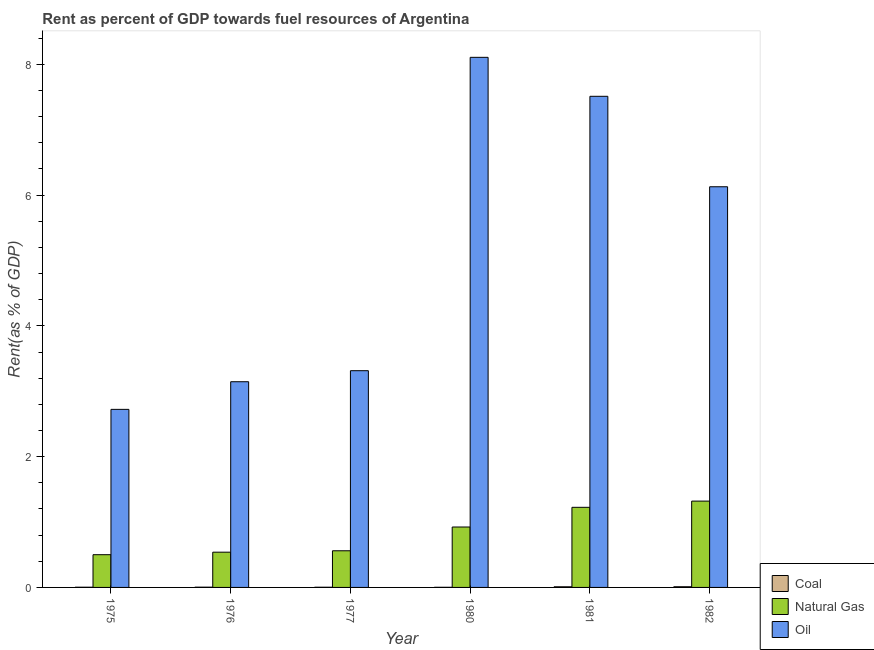Are the number of bars on each tick of the X-axis equal?
Offer a terse response. Yes. How many bars are there on the 1st tick from the left?
Your response must be concise. 3. How many bars are there on the 2nd tick from the right?
Provide a succinct answer. 3. What is the label of the 4th group of bars from the left?
Keep it short and to the point. 1980. What is the rent towards coal in 1982?
Your answer should be very brief. 0.01. Across all years, what is the maximum rent towards oil?
Provide a succinct answer. 8.11. Across all years, what is the minimum rent towards coal?
Give a very brief answer. 0. In which year was the rent towards oil minimum?
Provide a succinct answer. 1975. What is the total rent towards coal in the graph?
Provide a short and direct response. 0.03. What is the difference between the rent towards coal in 1981 and that in 1982?
Keep it short and to the point. -0. What is the difference between the rent towards coal in 1980 and the rent towards natural gas in 1977?
Ensure brevity in your answer.  -0. What is the average rent towards coal per year?
Provide a short and direct response. 0.01. In how many years, is the rent towards oil greater than 7.6 %?
Provide a succinct answer. 1. What is the ratio of the rent towards coal in 1977 to that in 1980?
Ensure brevity in your answer.  1.55. What is the difference between the highest and the second highest rent towards natural gas?
Your response must be concise. 0.1. What is the difference between the highest and the lowest rent towards natural gas?
Your answer should be compact. 0.82. Is the sum of the rent towards natural gas in 1975 and 1980 greater than the maximum rent towards oil across all years?
Ensure brevity in your answer.  Yes. What does the 1st bar from the left in 1976 represents?
Your response must be concise. Coal. What does the 2nd bar from the right in 1977 represents?
Your answer should be compact. Natural Gas. Is it the case that in every year, the sum of the rent towards coal and rent towards natural gas is greater than the rent towards oil?
Give a very brief answer. No. How many years are there in the graph?
Give a very brief answer. 6. Does the graph contain any zero values?
Provide a succinct answer. No. Does the graph contain grids?
Offer a very short reply. No. Where does the legend appear in the graph?
Provide a succinct answer. Bottom right. How are the legend labels stacked?
Keep it short and to the point. Vertical. What is the title of the graph?
Keep it short and to the point. Rent as percent of GDP towards fuel resources of Argentina. Does "Travel services" appear as one of the legend labels in the graph?
Offer a terse response. No. What is the label or title of the X-axis?
Provide a succinct answer. Year. What is the label or title of the Y-axis?
Give a very brief answer. Rent(as % of GDP). What is the Rent(as % of GDP) in Coal in 1975?
Your response must be concise. 0. What is the Rent(as % of GDP) in Natural Gas in 1975?
Ensure brevity in your answer.  0.5. What is the Rent(as % of GDP) of Oil in 1975?
Offer a very short reply. 2.72. What is the Rent(as % of GDP) in Coal in 1976?
Offer a very short reply. 0. What is the Rent(as % of GDP) in Natural Gas in 1976?
Offer a very short reply. 0.54. What is the Rent(as % of GDP) in Oil in 1976?
Your answer should be compact. 3.15. What is the Rent(as % of GDP) in Coal in 1977?
Make the answer very short. 0. What is the Rent(as % of GDP) in Natural Gas in 1977?
Offer a terse response. 0.56. What is the Rent(as % of GDP) in Oil in 1977?
Your answer should be very brief. 3.31. What is the Rent(as % of GDP) in Coal in 1980?
Keep it short and to the point. 0. What is the Rent(as % of GDP) in Natural Gas in 1980?
Offer a terse response. 0.92. What is the Rent(as % of GDP) of Oil in 1980?
Make the answer very short. 8.11. What is the Rent(as % of GDP) in Coal in 1981?
Make the answer very short. 0.01. What is the Rent(as % of GDP) of Natural Gas in 1981?
Offer a very short reply. 1.23. What is the Rent(as % of GDP) in Oil in 1981?
Provide a succinct answer. 7.51. What is the Rent(as % of GDP) of Coal in 1982?
Your answer should be compact. 0.01. What is the Rent(as % of GDP) in Natural Gas in 1982?
Offer a very short reply. 1.32. What is the Rent(as % of GDP) of Oil in 1982?
Your answer should be very brief. 6.13. Across all years, what is the maximum Rent(as % of GDP) in Coal?
Keep it short and to the point. 0.01. Across all years, what is the maximum Rent(as % of GDP) in Natural Gas?
Provide a short and direct response. 1.32. Across all years, what is the maximum Rent(as % of GDP) in Oil?
Your answer should be very brief. 8.11. Across all years, what is the minimum Rent(as % of GDP) in Coal?
Ensure brevity in your answer.  0. Across all years, what is the minimum Rent(as % of GDP) of Natural Gas?
Offer a very short reply. 0.5. Across all years, what is the minimum Rent(as % of GDP) of Oil?
Provide a succinct answer. 2.72. What is the total Rent(as % of GDP) of Coal in the graph?
Provide a short and direct response. 0.03. What is the total Rent(as % of GDP) in Natural Gas in the graph?
Give a very brief answer. 5.07. What is the total Rent(as % of GDP) of Oil in the graph?
Provide a succinct answer. 30.93. What is the difference between the Rent(as % of GDP) in Coal in 1975 and that in 1976?
Offer a very short reply. -0. What is the difference between the Rent(as % of GDP) in Natural Gas in 1975 and that in 1976?
Provide a short and direct response. -0.04. What is the difference between the Rent(as % of GDP) in Oil in 1975 and that in 1976?
Provide a succinct answer. -0.42. What is the difference between the Rent(as % of GDP) in Natural Gas in 1975 and that in 1977?
Your answer should be compact. -0.06. What is the difference between the Rent(as % of GDP) of Oil in 1975 and that in 1977?
Make the answer very short. -0.59. What is the difference between the Rent(as % of GDP) of Coal in 1975 and that in 1980?
Provide a succinct answer. 0. What is the difference between the Rent(as % of GDP) in Natural Gas in 1975 and that in 1980?
Offer a very short reply. -0.42. What is the difference between the Rent(as % of GDP) in Oil in 1975 and that in 1980?
Your response must be concise. -5.38. What is the difference between the Rent(as % of GDP) of Coal in 1975 and that in 1981?
Your answer should be very brief. -0.01. What is the difference between the Rent(as % of GDP) in Natural Gas in 1975 and that in 1981?
Give a very brief answer. -0.72. What is the difference between the Rent(as % of GDP) of Oil in 1975 and that in 1981?
Provide a succinct answer. -4.79. What is the difference between the Rent(as % of GDP) of Coal in 1975 and that in 1982?
Offer a very short reply. -0.01. What is the difference between the Rent(as % of GDP) in Natural Gas in 1975 and that in 1982?
Ensure brevity in your answer.  -0.82. What is the difference between the Rent(as % of GDP) in Oil in 1975 and that in 1982?
Make the answer very short. -3.4. What is the difference between the Rent(as % of GDP) in Coal in 1976 and that in 1977?
Make the answer very short. 0. What is the difference between the Rent(as % of GDP) of Natural Gas in 1976 and that in 1977?
Make the answer very short. -0.02. What is the difference between the Rent(as % of GDP) of Oil in 1976 and that in 1977?
Give a very brief answer. -0.17. What is the difference between the Rent(as % of GDP) of Coal in 1976 and that in 1980?
Ensure brevity in your answer.  0. What is the difference between the Rent(as % of GDP) of Natural Gas in 1976 and that in 1980?
Your answer should be very brief. -0.39. What is the difference between the Rent(as % of GDP) in Oil in 1976 and that in 1980?
Make the answer very short. -4.96. What is the difference between the Rent(as % of GDP) of Coal in 1976 and that in 1981?
Offer a terse response. -0.01. What is the difference between the Rent(as % of GDP) of Natural Gas in 1976 and that in 1981?
Provide a short and direct response. -0.69. What is the difference between the Rent(as % of GDP) in Oil in 1976 and that in 1981?
Make the answer very short. -4.37. What is the difference between the Rent(as % of GDP) in Coal in 1976 and that in 1982?
Ensure brevity in your answer.  -0.01. What is the difference between the Rent(as % of GDP) in Natural Gas in 1976 and that in 1982?
Provide a short and direct response. -0.78. What is the difference between the Rent(as % of GDP) in Oil in 1976 and that in 1982?
Provide a short and direct response. -2.98. What is the difference between the Rent(as % of GDP) of Natural Gas in 1977 and that in 1980?
Provide a succinct answer. -0.36. What is the difference between the Rent(as % of GDP) of Oil in 1977 and that in 1980?
Your response must be concise. -4.79. What is the difference between the Rent(as % of GDP) of Coal in 1977 and that in 1981?
Make the answer very short. -0.01. What is the difference between the Rent(as % of GDP) in Natural Gas in 1977 and that in 1981?
Offer a very short reply. -0.66. What is the difference between the Rent(as % of GDP) in Oil in 1977 and that in 1981?
Offer a terse response. -4.2. What is the difference between the Rent(as % of GDP) in Coal in 1977 and that in 1982?
Give a very brief answer. -0.01. What is the difference between the Rent(as % of GDP) of Natural Gas in 1977 and that in 1982?
Make the answer very short. -0.76. What is the difference between the Rent(as % of GDP) in Oil in 1977 and that in 1982?
Offer a very short reply. -2.81. What is the difference between the Rent(as % of GDP) of Coal in 1980 and that in 1981?
Your answer should be very brief. -0.01. What is the difference between the Rent(as % of GDP) in Natural Gas in 1980 and that in 1981?
Your answer should be very brief. -0.3. What is the difference between the Rent(as % of GDP) in Oil in 1980 and that in 1981?
Ensure brevity in your answer.  0.6. What is the difference between the Rent(as % of GDP) of Coal in 1980 and that in 1982?
Keep it short and to the point. -0.01. What is the difference between the Rent(as % of GDP) of Natural Gas in 1980 and that in 1982?
Your response must be concise. -0.4. What is the difference between the Rent(as % of GDP) of Oil in 1980 and that in 1982?
Your answer should be compact. 1.98. What is the difference between the Rent(as % of GDP) of Coal in 1981 and that in 1982?
Your answer should be compact. -0. What is the difference between the Rent(as % of GDP) in Natural Gas in 1981 and that in 1982?
Your answer should be compact. -0.1. What is the difference between the Rent(as % of GDP) of Oil in 1981 and that in 1982?
Provide a succinct answer. 1.38. What is the difference between the Rent(as % of GDP) in Coal in 1975 and the Rent(as % of GDP) in Natural Gas in 1976?
Offer a terse response. -0.54. What is the difference between the Rent(as % of GDP) of Coal in 1975 and the Rent(as % of GDP) of Oil in 1976?
Offer a very short reply. -3.14. What is the difference between the Rent(as % of GDP) in Natural Gas in 1975 and the Rent(as % of GDP) in Oil in 1976?
Your answer should be very brief. -2.65. What is the difference between the Rent(as % of GDP) of Coal in 1975 and the Rent(as % of GDP) of Natural Gas in 1977?
Provide a succinct answer. -0.56. What is the difference between the Rent(as % of GDP) in Coal in 1975 and the Rent(as % of GDP) in Oil in 1977?
Keep it short and to the point. -3.31. What is the difference between the Rent(as % of GDP) of Natural Gas in 1975 and the Rent(as % of GDP) of Oil in 1977?
Give a very brief answer. -2.81. What is the difference between the Rent(as % of GDP) of Coal in 1975 and the Rent(as % of GDP) of Natural Gas in 1980?
Give a very brief answer. -0.92. What is the difference between the Rent(as % of GDP) in Coal in 1975 and the Rent(as % of GDP) in Oil in 1980?
Offer a terse response. -8.1. What is the difference between the Rent(as % of GDP) of Natural Gas in 1975 and the Rent(as % of GDP) of Oil in 1980?
Provide a short and direct response. -7.61. What is the difference between the Rent(as % of GDP) of Coal in 1975 and the Rent(as % of GDP) of Natural Gas in 1981?
Offer a terse response. -1.22. What is the difference between the Rent(as % of GDP) of Coal in 1975 and the Rent(as % of GDP) of Oil in 1981?
Give a very brief answer. -7.51. What is the difference between the Rent(as % of GDP) of Natural Gas in 1975 and the Rent(as % of GDP) of Oil in 1981?
Your response must be concise. -7.01. What is the difference between the Rent(as % of GDP) of Coal in 1975 and the Rent(as % of GDP) of Natural Gas in 1982?
Provide a short and direct response. -1.32. What is the difference between the Rent(as % of GDP) in Coal in 1975 and the Rent(as % of GDP) in Oil in 1982?
Give a very brief answer. -6.12. What is the difference between the Rent(as % of GDP) in Natural Gas in 1975 and the Rent(as % of GDP) in Oil in 1982?
Ensure brevity in your answer.  -5.63. What is the difference between the Rent(as % of GDP) of Coal in 1976 and the Rent(as % of GDP) of Natural Gas in 1977?
Give a very brief answer. -0.56. What is the difference between the Rent(as % of GDP) in Coal in 1976 and the Rent(as % of GDP) in Oil in 1977?
Make the answer very short. -3.31. What is the difference between the Rent(as % of GDP) in Natural Gas in 1976 and the Rent(as % of GDP) in Oil in 1977?
Offer a very short reply. -2.78. What is the difference between the Rent(as % of GDP) in Coal in 1976 and the Rent(as % of GDP) in Natural Gas in 1980?
Your answer should be compact. -0.92. What is the difference between the Rent(as % of GDP) in Coal in 1976 and the Rent(as % of GDP) in Oil in 1980?
Your answer should be compact. -8.1. What is the difference between the Rent(as % of GDP) of Natural Gas in 1976 and the Rent(as % of GDP) of Oil in 1980?
Ensure brevity in your answer.  -7.57. What is the difference between the Rent(as % of GDP) in Coal in 1976 and the Rent(as % of GDP) in Natural Gas in 1981?
Your response must be concise. -1.22. What is the difference between the Rent(as % of GDP) of Coal in 1976 and the Rent(as % of GDP) of Oil in 1981?
Offer a very short reply. -7.51. What is the difference between the Rent(as % of GDP) in Natural Gas in 1976 and the Rent(as % of GDP) in Oil in 1981?
Offer a very short reply. -6.97. What is the difference between the Rent(as % of GDP) of Coal in 1976 and the Rent(as % of GDP) of Natural Gas in 1982?
Give a very brief answer. -1.32. What is the difference between the Rent(as % of GDP) of Coal in 1976 and the Rent(as % of GDP) of Oil in 1982?
Provide a short and direct response. -6.12. What is the difference between the Rent(as % of GDP) in Natural Gas in 1976 and the Rent(as % of GDP) in Oil in 1982?
Make the answer very short. -5.59. What is the difference between the Rent(as % of GDP) in Coal in 1977 and the Rent(as % of GDP) in Natural Gas in 1980?
Your answer should be very brief. -0.92. What is the difference between the Rent(as % of GDP) of Coal in 1977 and the Rent(as % of GDP) of Oil in 1980?
Make the answer very short. -8.1. What is the difference between the Rent(as % of GDP) in Natural Gas in 1977 and the Rent(as % of GDP) in Oil in 1980?
Offer a very short reply. -7.55. What is the difference between the Rent(as % of GDP) in Coal in 1977 and the Rent(as % of GDP) in Natural Gas in 1981?
Offer a terse response. -1.22. What is the difference between the Rent(as % of GDP) of Coal in 1977 and the Rent(as % of GDP) of Oil in 1981?
Your answer should be compact. -7.51. What is the difference between the Rent(as % of GDP) of Natural Gas in 1977 and the Rent(as % of GDP) of Oil in 1981?
Give a very brief answer. -6.95. What is the difference between the Rent(as % of GDP) of Coal in 1977 and the Rent(as % of GDP) of Natural Gas in 1982?
Give a very brief answer. -1.32. What is the difference between the Rent(as % of GDP) of Coal in 1977 and the Rent(as % of GDP) of Oil in 1982?
Provide a short and direct response. -6.13. What is the difference between the Rent(as % of GDP) of Natural Gas in 1977 and the Rent(as % of GDP) of Oil in 1982?
Your response must be concise. -5.57. What is the difference between the Rent(as % of GDP) in Coal in 1980 and the Rent(as % of GDP) in Natural Gas in 1981?
Offer a very short reply. -1.22. What is the difference between the Rent(as % of GDP) of Coal in 1980 and the Rent(as % of GDP) of Oil in 1981?
Keep it short and to the point. -7.51. What is the difference between the Rent(as % of GDP) of Natural Gas in 1980 and the Rent(as % of GDP) of Oil in 1981?
Make the answer very short. -6.59. What is the difference between the Rent(as % of GDP) in Coal in 1980 and the Rent(as % of GDP) in Natural Gas in 1982?
Your answer should be very brief. -1.32. What is the difference between the Rent(as % of GDP) of Coal in 1980 and the Rent(as % of GDP) of Oil in 1982?
Your response must be concise. -6.13. What is the difference between the Rent(as % of GDP) in Natural Gas in 1980 and the Rent(as % of GDP) in Oil in 1982?
Give a very brief answer. -5.2. What is the difference between the Rent(as % of GDP) in Coal in 1981 and the Rent(as % of GDP) in Natural Gas in 1982?
Keep it short and to the point. -1.31. What is the difference between the Rent(as % of GDP) of Coal in 1981 and the Rent(as % of GDP) of Oil in 1982?
Provide a succinct answer. -6.12. What is the difference between the Rent(as % of GDP) in Natural Gas in 1981 and the Rent(as % of GDP) in Oil in 1982?
Offer a terse response. -4.9. What is the average Rent(as % of GDP) in Coal per year?
Keep it short and to the point. 0.01. What is the average Rent(as % of GDP) of Natural Gas per year?
Your response must be concise. 0.84. What is the average Rent(as % of GDP) in Oil per year?
Give a very brief answer. 5.15. In the year 1975, what is the difference between the Rent(as % of GDP) of Coal and Rent(as % of GDP) of Natural Gas?
Your answer should be very brief. -0.5. In the year 1975, what is the difference between the Rent(as % of GDP) in Coal and Rent(as % of GDP) in Oil?
Make the answer very short. -2.72. In the year 1975, what is the difference between the Rent(as % of GDP) of Natural Gas and Rent(as % of GDP) of Oil?
Provide a short and direct response. -2.22. In the year 1976, what is the difference between the Rent(as % of GDP) of Coal and Rent(as % of GDP) of Natural Gas?
Your response must be concise. -0.54. In the year 1976, what is the difference between the Rent(as % of GDP) in Coal and Rent(as % of GDP) in Oil?
Ensure brevity in your answer.  -3.14. In the year 1976, what is the difference between the Rent(as % of GDP) in Natural Gas and Rent(as % of GDP) in Oil?
Offer a very short reply. -2.61. In the year 1977, what is the difference between the Rent(as % of GDP) in Coal and Rent(as % of GDP) in Natural Gas?
Your answer should be compact. -0.56. In the year 1977, what is the difference between the Rent(as % of GDP) of Coal and Rent(as % of GDP) of Oil?
Ensure brevity in your answer.  -3.31. In the year 1977, what is the difference between the Rent(as % of GDP) of Natural Gas and Rent(as % of GDP) of Oil?
Ensure brevity in your answer.  -2.75. In the year 1980, what is the difference between the Rent(as % of GDP) in Coal and Rent(as % of GDP) in Natural Gas?
Keep it short and to the point. -0.92. In the year 1980, what is the difference between the Rent(as % of GDP) in Coal and Rent(as % of GDP) in Oil?
Offer a very short reply. -8.11. In the year 1980, what is the difference between the Rent(as % of GDP) in Natural Gas and Rent(as % of GDP) in Oil?
Your answer should be compact. -7.18. In the year 1981, what is the difference between the Rent(as % of GDP) of Coal and Rent(as % of GDP) of Natural Gas?
Offer a very short reply. -1.22. In the year 1981, what is the difference between the Rent(as % of GDP) of Coal and Rent(as % of GDP) of Oil?
Provide a succinct answer. -7.5. In the year 1981, what is the difference between the Rent(as % of GDP) in Natural Gas and Rent(as % of GDP) in Oil?
Your answer should be very brief. -6.29. In the year 1982, what is the difference between the Rent(as % of GDP) in Coal and Rent(as % of GDP) in Natural Gas?
Keep it short and to the point. -1.31. In the year 1982, what is the difference between the Rent(as % of GDP) of Coal and Rent(as % of GDP) of Oil?
Make the answer very short. -6.12. In the year 1982, what is the difference between the Rent(as % of GDP) of Natural Gas and Rent(as % of GDP) of Oil?
Provide a succinct answer. -4.81. What is the ratio of the Rent(as % of GDP) of Coal in 1975 to that in 1976?
Your answer should be compact. 0.79. What is the ratio of the Rent(as % of GDP) in Natural Gas in 1975 to that in 1976?
Ensure brevity in your answer.  0.93. What is the ratio of the Rent(as % of GDP) of Oil in 1975 to that in 1976?
Your response must be concise. 0.87. What is the ratio of the Rent(as % of GDP) of Coal in 1975 to that in 1977?
Offer a terse response. 1.13. What is the ratio of the Rent(as % of GDP) of Natural Gas in 1975 to that in 1977?
Ensure brevity in your answer.  0.89. What is the ratio of the Rent(as % of GDP) in Oil in 1975 to that in 1977?
Provide a succinct answer. 0.82. What is the ratio of the Rent(as % of GDP) of Coal in 1975 to that in 1980?
Your answer should be compact. 1.75. What is the ratio of the Rent(as % of GDP) of Natural Gas in 1975 to that in 1980?
Provide a succinct answer. 0.54. What is the ratio of the Rent(as % of GDP) in Oil in 1975 to that in 1980?
Your answer should be compact. 0.34. What is the ratio of the Rent(as % of GDP) in Coal in 1975 to that in 1981?
Keep it short and to the point. 0.31. What is the ratio of the Rent(as % of GDP) in Natural Gas in 1975 to that in 1981?
Make the answer very short. 0.41. What is the ratio of the Rent(as % of GDP) of Oil in 1975 to that in 1981?
Provide a short and direct response. 0.36. What is the ratio of the Rent(as % of GDP) in Coal in 1975 to that in 1982?
Make the answer very short. 0.29. What is the ratio of the Rent(as % of GDP) of Natural Gas in 1975 to that in 1982?
Provide a succinct answer. 0.38. What is the ratio of the Rent(as % of GDP) of Oil in 1975 to that in 1982?
Give a very brief answer. 0.44. What is the ratio of the Rent(as % of GDP) in Coal in 1976 to that in 1977?
Your answer should be compact. 1.43. What is the ratio of the Rent(as % of GDP) of Natural Gas in 1976 to that in 1977?
Provide a succinct answer. 0.96. What is the ratio of the Rent(as % of GDP) of Oil in 1976 to that in 1977?
Make the answer very short. 0.95. What is the ratio of the Rent(as % of GDP) in Coal in 1976 to that in 1980?
Provide a short and direct response. 2.22. What is the ratio of the Rent(as % of GDP) of Natural Gas in 1976 to that in 1980?
Ensure brevity in your answer.  0.58. What is the ratio of the Rent(as % of GDP) of Oil in 1976 to that in 1980?
Keep it short and to the point. 0.39. What is the ratio of the Rent(as % of GDP) in Coal in 1976 to that in 1981?
Provide a short and direct response. 0.4. What is the ratio of the Rent(as % of GDP) in Natural Gas in 1976 to that in 1981?
Your answer should be compact. 0.44. What is the ratio of the Rent(as % of GDP) in Oil in 1976 to that in 1981?
Offer a very short reply. 0.42. What is the ratio of the Rent(as % of GDP) of Coal in 1976 to that in 1982?
Your answer should be very brief. 0.37. What is the ratio of the Rent(as % of GDP) of Natural Gas in 1976 to that in 1982?
Make the answer very short. 0.41. What is the ratio of the Rent(as % of GDP) of Oil in 1976 to that in 1982?
Keep it short and to the point. 0.51. What is the ratio of the Rent(as % of GDP) of Coal in 1977 to that in 1980?
Give a very brief answer. 1.55. What is the ratio of the Rent(as % of GDP) in Natural Gas in 1977 to that in 1980?
Provide a succinct answer. 0.61. What is the ratio of the Rent(as % of GDP) in Oil in 1977 to that in 1980?
Give a very brief answer. 0.41. What is the ratio of the Rent(as % of GDP) in Coal in 1977 to that in 1981?
Ensure brevity in your answer.  0.28. What is the ratio of the Rent(as % of GDP) in Natural Gas in 1977 to that in 1981?
Offer a very short reply. 0.46. What is the ratio of the Rent(as % of GDP) in Oil in 1977 to that in 1981?
Provide a succinct answer. 0.44. What is the ratio of the Rent(as % of GDP) in Coal in 1977 to that in 1982?
Offer a very short reply. 0.26. What is the ratio of the Rent(as % of GDP) of Natural Gas in 1977 to that in 1982?
Your answer should be very brief. 0.42. What is the ratio of the Rent(as % of GDP) of Oil in 1977 to that in 1982?
Your response must be concise. 0.54. What is the ratio of the Rent(as % of GDP) in Coal in 1980 to that in 1981?
Provide a succinct answer. 0.18. What is the ratio of the Rent(as % of GDP) of Natural Gas in 1980 to that in 1981?
Offer a terse response. 0.75. What is the ratio of the Rent(as % of GDP) of Oil in 1980 to that in 1981?
Keep it short and to the point. 1.08. What is the ratio of the Rent(as % of GDP) in Coal in 1980 to that in 1982?
Offer a terse response. 0.17. What is the ratio of the Rent(as % of GDP) in Natural Gas in 1980 to that in 1982?
Ensure brevity in your answer.  0.7. What is the ratio of the Rent(as % of GDP) of Oil in 1980 to that in 1982?
Your response must be concise. 1.32. What is the ratio of the Rent(as % of GDP) in Coal in 1981 to that in 1982?
Your response must be concise. 0.92. What is the ratio of the Rent(as % of GDP) in Natural Gas in 1981 to that in 1982?
Your answer should be very brief. 0.93. What is the ratio of the Rent(as % of GDP) of Oil in 1981 to that in 1982?
Ensure brevity in your answer.  1.23. What is the difference between the highest and the second highest Rent(as % of GDP) of Coal?
Keep it short and to the point. 0. What is the difference between the highest and the second highest Rent(as % of GDP) in Natural Gas?
Your answer should be compact. 0.1. What is the difference between the highest and the second highest Rent(as % of GDP) in Oil?
Your answer should be very brief. 0.6. What is the difference between the highest and the lowest Rent(as % of GDP) in Coal?
Offer a very short reply. 0.01. What is the difference between the highest and the lowest Rent(as % of GDP) in Natural Gas?
Your answer should be compact. 0.82. What is the difference between the highest and the lowest Rent(as % of GDP) of Oil?
Your answer should be very brief. 5.38. 